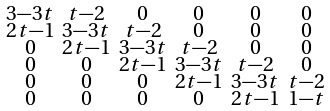Convert formula to latex. <formula><loc_0><loc_0><loc_500><loc_500>\begin{smallmatrix} 3 - 3 t & t - 2 & 0 & 0 & 0 & 0 \\ 2 t - 1 & 3 - 3 t & t - 2 & 0 & 0 & 0 \\ 0 & 2 t - 1 & 3 - 3 t & t - 2 & 0 & 0 \\ 0 & 0 & 2 t - 1 & 3 - 3 t & t - 2 & 0 \\ 0 & 0 & 0 & 2 t - 1 & 3 - 3 t & t - 2 \\ 0 & 0 & 0 & 0 & 2 t - 1 & 1 - t \\ \end{smallmatrix}</formula> 